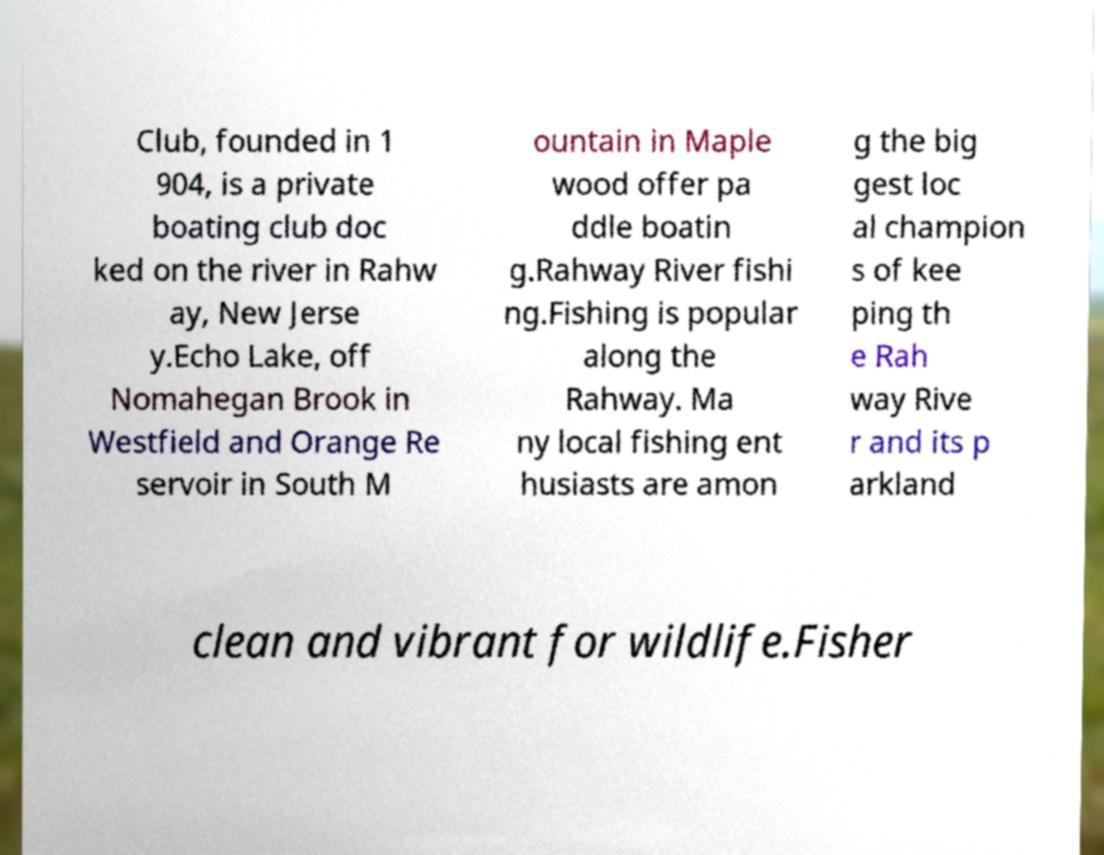I need the written content from this picture converted into text. Can you do that? Club, founded in 1 904, is a private boating club doc ked on the river in Rahw ay, New Jerse y.Echo Lake, off Nomahegan Brook in Westfield and Orange Re servoir in South M ountain in Maple wood offer pa ddle boatin g.Rahway River fishi ng.Fishing is popular along the Rahway. Ma ny local fishing ent husiasts are amon g the big gest loc al champion s of kee ping th e Rah way Rive r and its p arkland clean and vibrant for wildlife.Fisher 